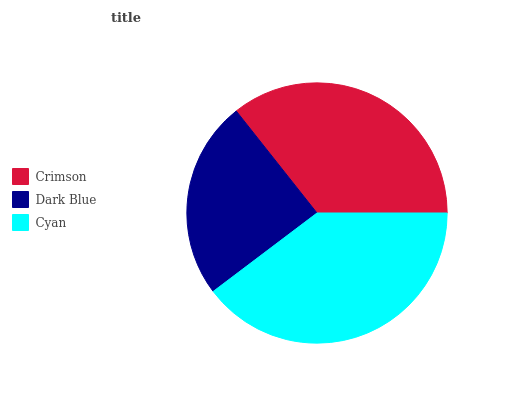Is Dark Blue the minimum?
Answer yes or no. Yes. Is Cyan the maximum?
Answer yes or no. Yes. Is Cyan the minimum?
Answer yes or no. No. Is Dark Blue the maximum?
Answer yes or no. No. Is Cyan greater than Dark Blue?
Answer yes or no. Yes. Is Dark Blue less than Cyan?
Answer yes or no. Yes. Is Dark Blue greater than Cyan?
Answer yes or no. No. Is Cyan less than Dark Blue?
Answer yes or no. No. Is Crimson the high median?
Answer yes or no. Yes. Is Crimson the low median?
Answer yes or no. Yes. Is Dark Blue the high median?
Answer yes or no. No. Is Cyan the low median?
Answer yes or no. No. 